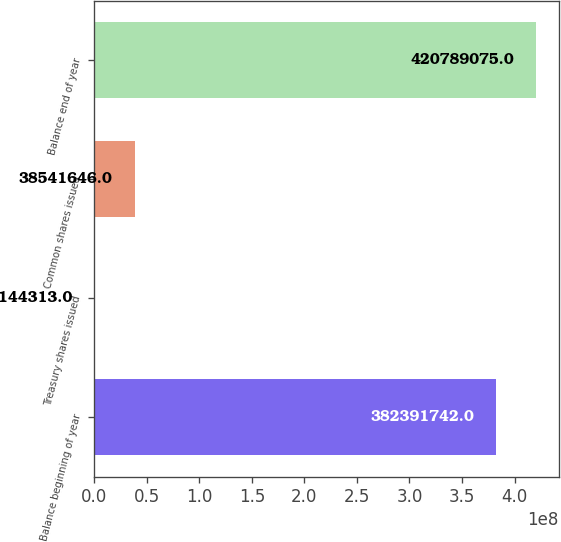Convert chart. <chart><loc_0><loc_0><loc_500><loc_500><bar_chart><fcel>Balance beginning of year<fcel>Treasury shares issued<fcel>Common shares issued<fcel>Balance end of year<nl><fcel>3.82392e+08<fcel>144313<fcel>3.85416e+07<fcel>4.20789e+08<nl></chart> 